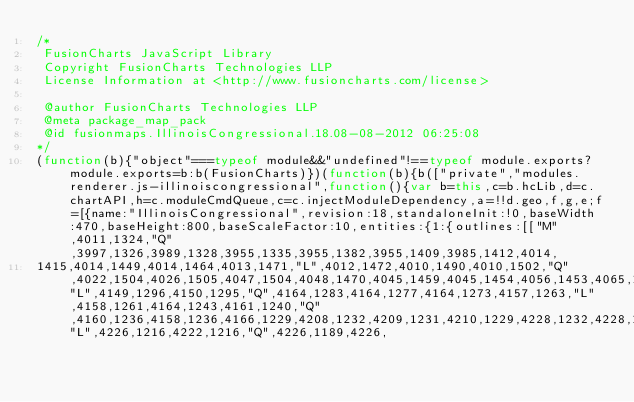<code> <loc_0><loc_0><loc_500><loc_500><_JavaScript_>/*
 FusionCharts JavaScript Library
 Copyright FusionCharts Technologies LLP
 License Information at <http://www.fusioncharts.com/license>

 @author FusionCharts Technologies LLP
 @meta package_map_pack
 @id fusionmaps.IllinoisCongressional.18.08-08-2012 06:25:08
*/
(function(b){"object"===typeof module&&"undefined"!==typeof module.exports?module.exports=b:b(FusionCharts)})(function(b){b(["private","modules.renderer.js-illinoiscongressional",function(){var b=this,c=b.hcLib,d=c.chartAPI,h=c.moduleCmdQueue,c=c.injectModuleDependency,a=!!d.geo,f,g,e;f=[{name:"IllinoisCongressional",revision:18,standaloneInit:!0,baseWidth:470,baseHeight:800,baseScaleFactor:10,entities:{1:{outlines:[["M",4011,1324,"Q",3997,1326,3989,1328,3955,1335,3955,1382,3955,1409,3985,1412,4014,
1415,4014,1449,4014,1464,4013,1471,"L",4012,1472,4010,1490,4010,1502,"Q",4022,1504,4026,1505,4047,1504,4048,1470,4045,1459,4045,1454,4056,1453,4065,1441,4066,1440,4068,1438,4079,1428,4080,1420,4104,1416,4119,1382,4131,1354,4157,1360,4152,1351,4149,1351,"L",4149,1296,4150,1295,"Q",4164,1283,4164,1277,4164,1273,4157,1263,"L",4158,1261,4164,1243,4161,1240,"Q",4160,1236,4158,1236,4166,1229,4208,1232,4209,1231,4210,1229,4228,1232,4228,1217,4228,1216,4228,1215,"L",4226,1216,4222,1216,"Q",4226,1189,4226,</code> 